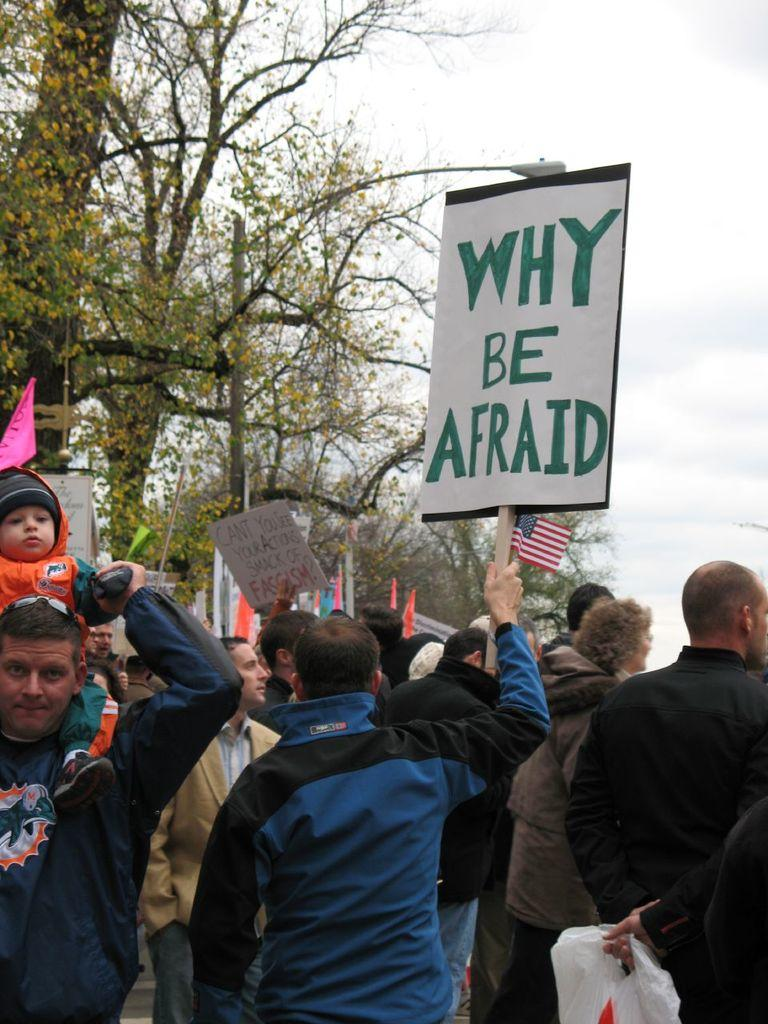<image>
Relay a brief, clear account of the picture shown. A protester holds a sign which asks why be afraid. 